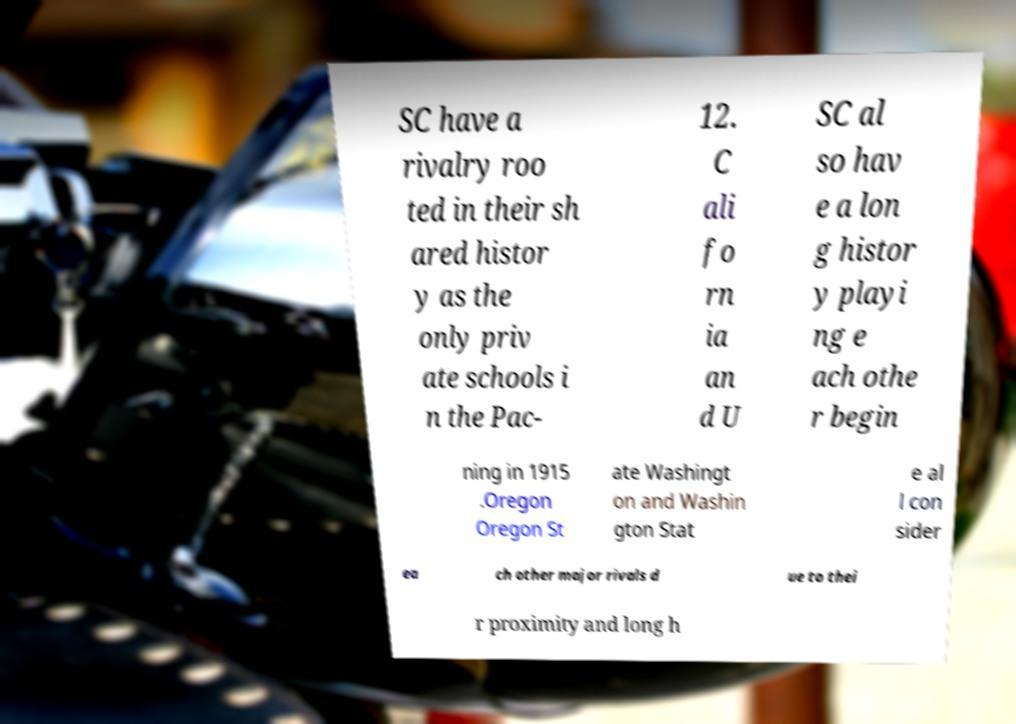What messages or text are displayed in this image? I need them in a readable, typed format. SC have a rivalry roo ted in their sh ared histor y as the only priv ate schools i n the Pac- 12. C ali fo rn ia an d U SC al so hav e a lon g histor y playi ng e ach othe r begin ning in 1915 .Oregon Oregon St ate Washingt on and Washin gton Stat e al l con sider ea ch other major rivals d ue to thei r proximity and long h 